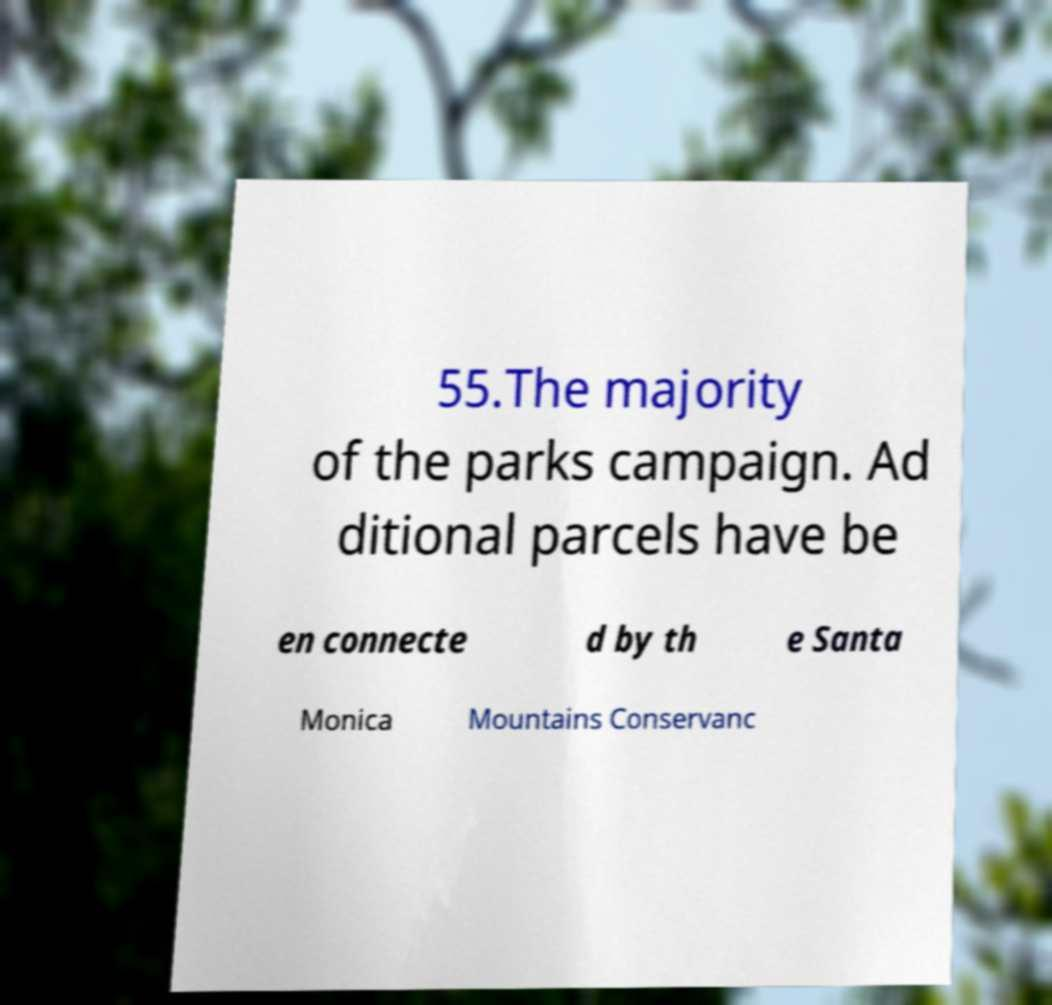Please identify and transcribe the text found in this image. 55.The majority of the parks campaign. Ad ditional parcels have be en connecte d by th e Santa Monica Mountains Conservanc 